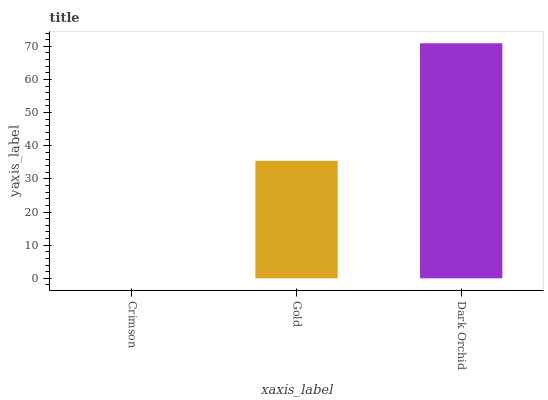Is Crimson the minimum?
Answer yes or no. Yes. Is Dark Orchid the maximum?
Answer yes or no. Yes. Is Gold the minimum?
Answer yes or no. No. Is Gold the maximum?
Answer yes or no. No. Is Gold greater than Crimson?
Answer yes or no. Yes. Is Crimson less than Gold?
Answer yes or no. Yes. Is Crimson greater than Gold?
Answer yes or no. No. Is Gold less than Crimson?
Answer yes or no. No. Is Gold the high median?
Answer yes or no. Yes. Is Gold the low median?
Answer yes or no. Yes. Is Dark Orchid the high median?
Answer yes or no. No. Is Dark Orchid the low median?
Answer yes or no. No. 